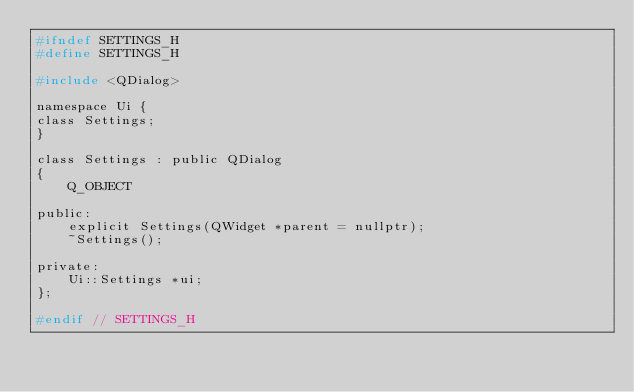Convert code to text. <code><loc_0><loc_0><loc_500><loc_500><_C_>#ifndef SETTINGS_H
#define SETTINGS_H

#include <QDialog>

namespace Ui {
class Settings;
}

class Settings : public QDialog
{
    Q_OBJECT

public:
    explicit Settings(QWidget *parent = nullptr);
    ~Settings();

private:
    Ui::Settings *ui;
};

#endif // SETTINGS_H
</code> 